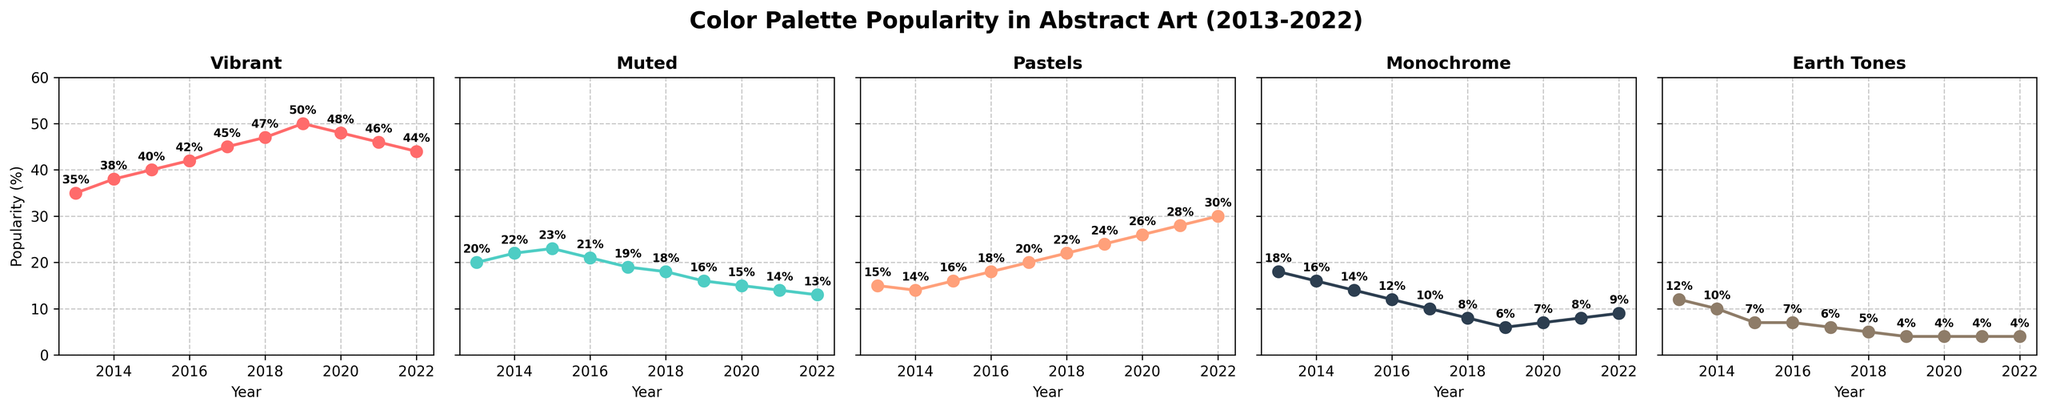What year had the highest popularity for Vibrant colors? To determine the year with the highest popularity for Vibrant colors, look at the subplot titled "Vibrant" and identify the data point with the highest value. The year corresponding to the highest data point is the one with the highest popularity. In this case, the highest value in the Vibrant subplot is 50%, which occurs in 2019.
Answer: 2019 Which color palette shows a consistent decrease in popularity over the years? To identify the color palette with a consistent decrease in popularity, examine the trends in each subplot. Notice that the "Muted" subplot shows decreasing values each year from 2013 (20%) to 2022 (13%), indicating a consistent downward trend.
Answer: Muted In what year did Pastels become more popular than Monochrome for the first time? To find the year when Pastels first surpassed Monochrome in popularity, compare the values in their respective subplots. Note that in 2016, Pastels (18%) first exceeds Monochrome (12%).
Answer: 2016 What is the average popularity of Earth Tones from 2018 to 2022? To calculate the average popularity of Earth Tones from 2018 to 2022, sum the values for these years and divide by the number of years. The values are 5, 4, 4, 4, 4. The sum is \(5 + 4 + 4 + 4 + 4 = 21\). Then divide by 5, \(21 / 5 = 4.2\).
Answer: 4.2 Compare the trend of Vibrant and Muted color palettes from 2013 to 2022. Which one shows a stronger increasing or decreasing trend? To compare the trends, examine the slopes in their respective subplots. Vibrant shows a significant increase from 35% in 2013 to 44% in 2022, whereas Muted decreases from 20% in 2013 to 13% in 2022. Vibrant shows a stronger increasing trend, and Muted shows a stronger decreasing trend.
Answer: Vibrant stronger increase, Muted stronger decrease How many years did Earth Tones have a popularity of 5% or less? Count the years in the Earth Tones subplot where the popularity percentage is 5 or less. The years are 2017, 2018, 2019, 2020, 2021, and 2022, which totals 6 years.
Answer: 6 Which palette had the least change in popularity over the decade? To determine the palette with the least change, compare the difference between the highest and lowest values in each subplot. Monochrome has the least change, ranging from 6% to 18%, with a difference of 12%. All other palettes have larger differences.
Answer: Monochrome What is the total increase in popularity for Pastels from 2013 to 2022? Calculate the difference in the values for Pastels between 2022 and 2013. The value in 2022 is 30%, and in 2013 it was 15%. The difference is \(30 - 15 = 15\).
Answer: 15 If you combine Pastels and Earth Tones, what was their highest combined popularity in a single year, and in which year did it occur? To find the highest combined popularity, sum the values of Pastels and Earth Tones for each year, and identify the maximum sum. The highest combined value is in 2022 with Pastels (30%) and Earth Tones (4%) totaling \(30 + 4 = 34\).
Answer: 34 in 2022 